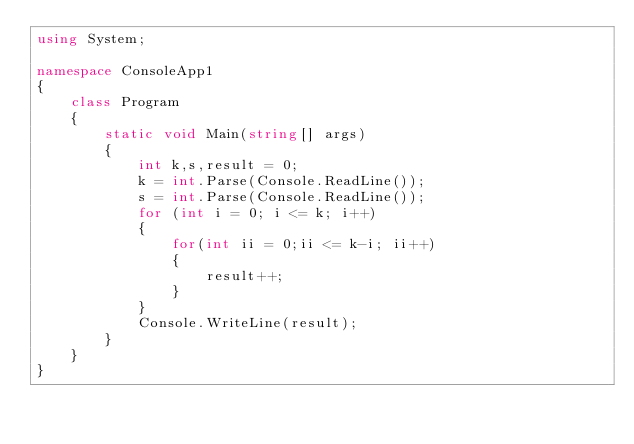<code> <loc_0><loc_0><loc_500><loc_500><_C#_>using System;

namespace ConsoleApp1
{
    class Program
    {
        static void Main(string[] args)
        {
            int k,s,result = 0;
            k = int.Parse(Console.ReadLine());
            s = int.Parse(Console.ReadLine());
            for (int i = 0; i <= k; i++)
            {
                for(int ii = 0;ii <= k-i; ii++)
                {
                    result++;
                }
            }
            Console.WriteLine(result);
        }
    }
}</code> 